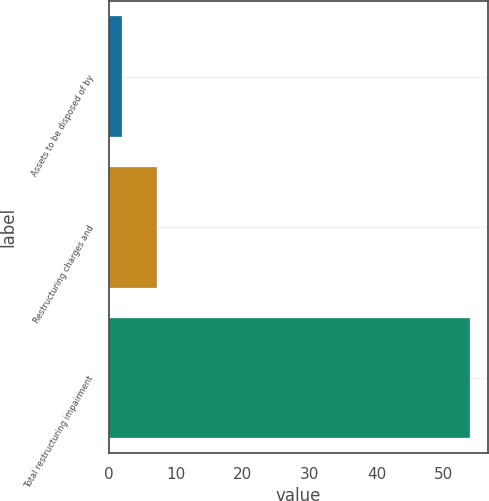Convert chart to OTSL. <chart><loc_0><loc_0><loc_500><loc_500><bar_chart><fcel>Assets to be disposed of by<fcel>Restructuring charges and<fcel>Total restructuring impairment<nl><fcel>2<fcel>7.2<fcel>54<nl></chart> 